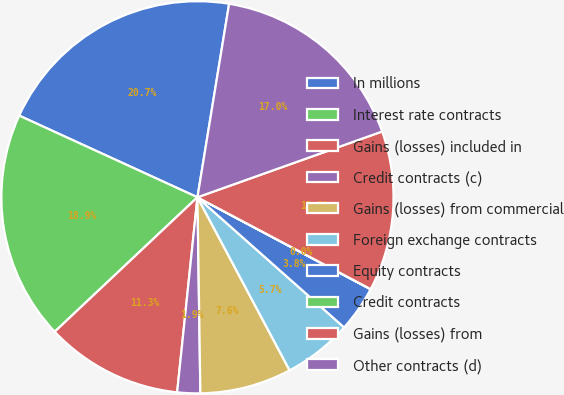Convert chart to OTSL. <chart><loc_0><loc_0><loc_500><loc_500><pie_chart><fcel>In millions<fcel>Interest rate contracts<fcel>Gains (losses) included in<fcel>Credit contracts (c)<fcel>Gains (losses) from commercial<fcel>Foreign exchange contracts<fcel>Equity contracts<fcel>Credit contracts<fcel>Gains (losses) from<fcel>Other contracts (d)<nl><fcel>20.74%<fcel>18.86%<fcel>11.32%<fcel>1.89%<fcel>7.55%<fcel>5.66%<fcel>3.78%<fcel>0.01%<fcel>13.2%<fcel>16.97%<nl></chart> 